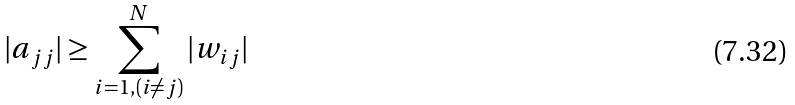Convert formula to latex. <formula><loc_0><loc_0><loc_500><loc_500>| a _ { j j } | \geq \sum _ { i = 1 , ( i \neq j ) } ^ { N } | w _ { i j } |</formula> 